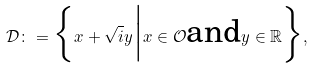<formula> <loc_0><loc_0><loc_500><loc_500>\mathcal { D } \colon = \Big \{ x + \sqrt { i } y \Big | x \in \mathcal { O } \text {and} y \in \mathbb { R } \Big \} ,</formula> 